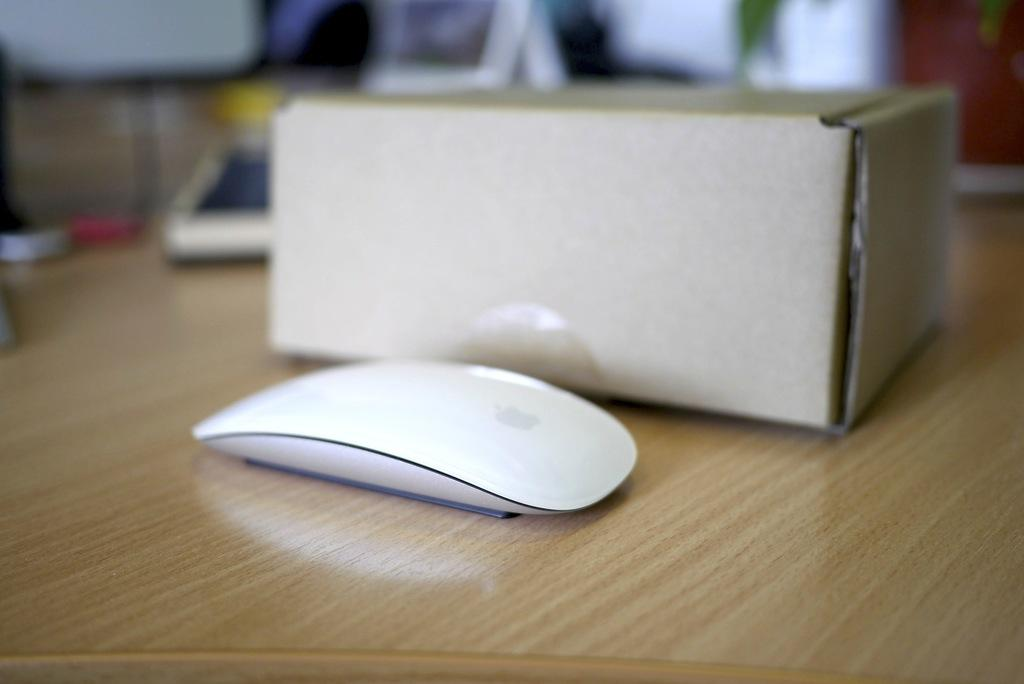What is the main object in the center of the image? There is a box in the center of the image. What other animal can be seen on the table? A mouse is placed on the table. Where are the box and mouse located? The box and mouse are on a table. What else can be seen in the image? There are other objects visible in the background of the image. What type of wine is being served on the beds in the image? There are no beds or wine present in the image; it features a box and a mouse on a table. 